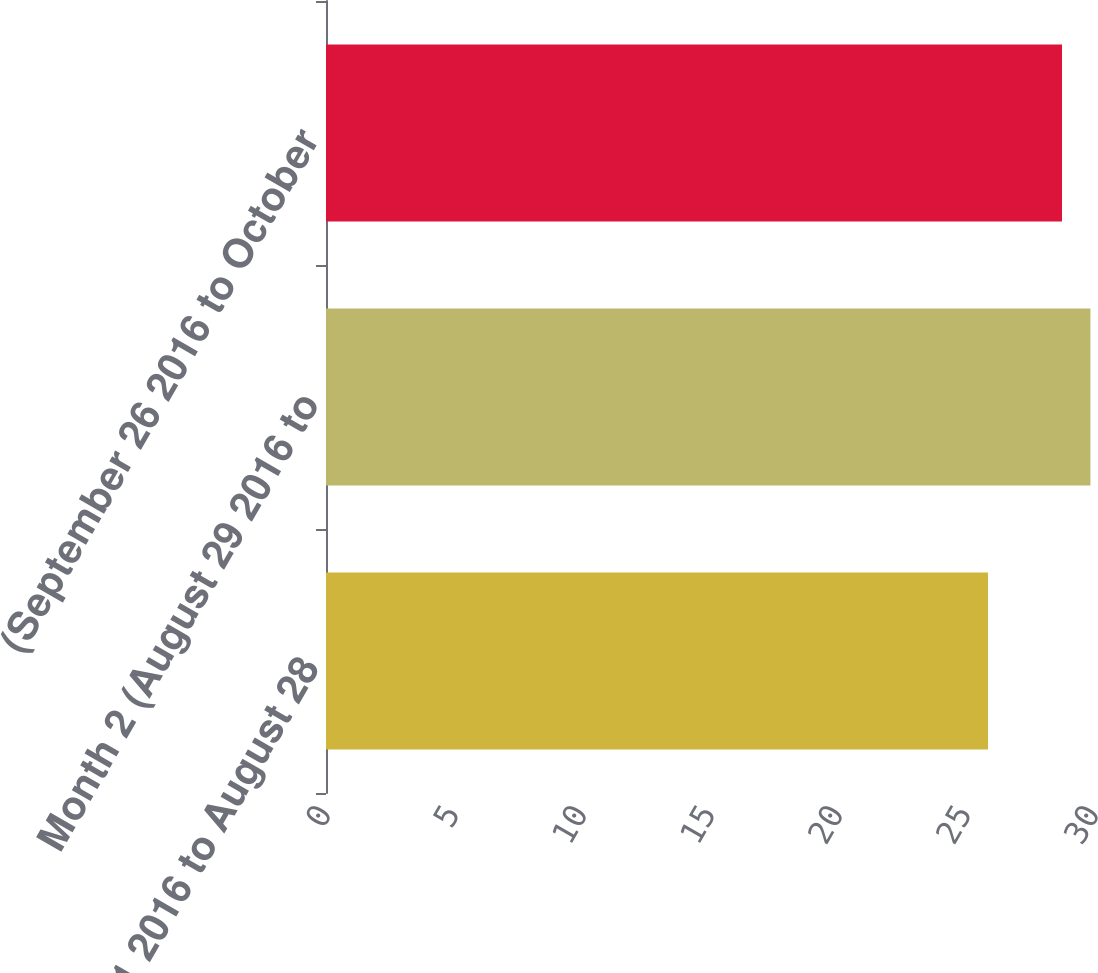Convert chart. <chart><loc_0><loc_0><loc_500><loc_500><bar_chart><fcel>(August 1 2016 to August 28<fcel>Month 2 (August 29 2016 to<fcel>(September 26 2016 to October<nl><fcel>25.86<fcel>29.86<fcel>28.75<nl></chart> 